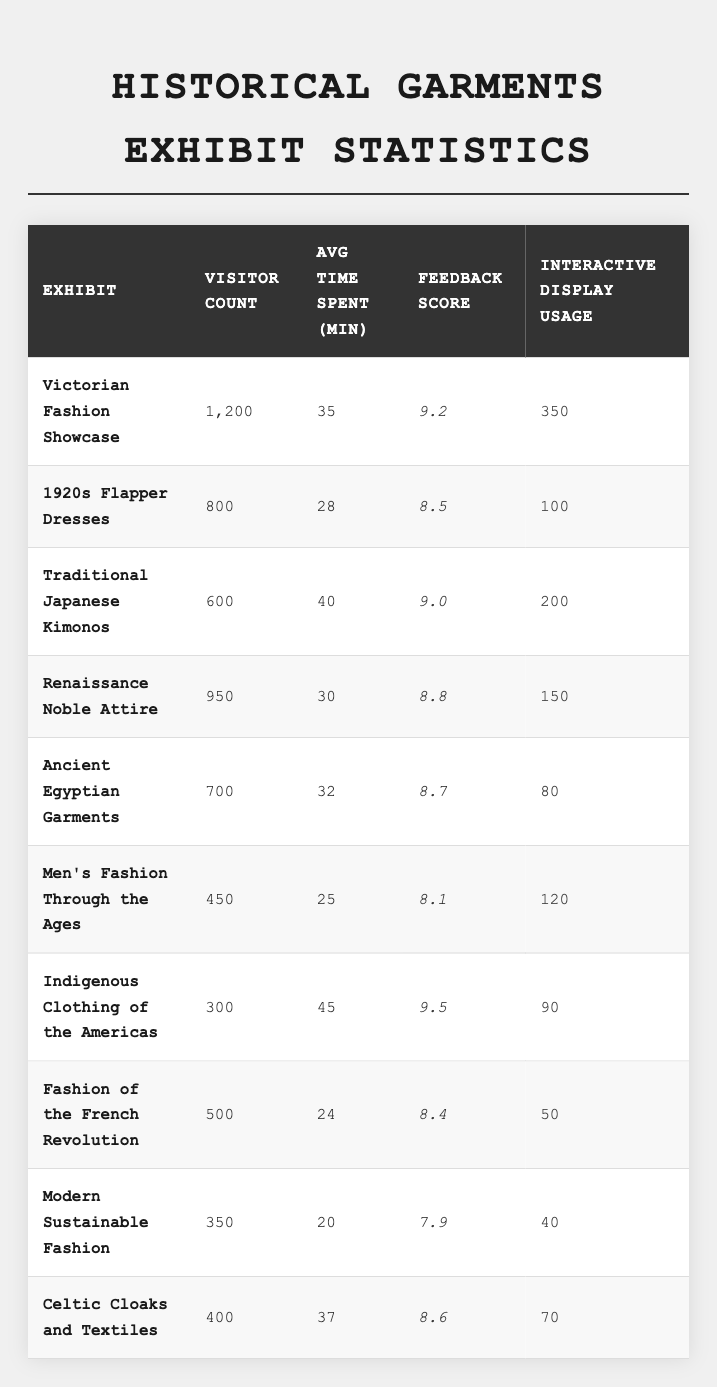What is the feedback score for the "Victorian Fashion Showcase"? The feedback score for the "Victorian Fashion Showcase" is listed in the table under the respective column, which shows a score of 9.2.
Answer: 9.2 Which exhibit had the highest visitor count? Looking at the visitor counts for each exhibit listed in the table, the "Victorian Fashion Showcase" has the highest count at 1200 visitors.
Answer: Victorian Fashion Showcase What is the average time spent by visitors at the "Traditional Japanese Kimonos" exhibit? The table indicates that visitors spent an average of 40 minutes at the "Traditional Japanese Kimonos" exhibit, which is the value in the corresponding row.
Answer: 40 minutes How many visitors engaged with the interactive display for the "1920s Flapper Dresses"? The table shows that for the "1920s Flapper Dresses" exhibit, the interactive display was used by 100 visitors according to the data provided.
Answer: 100 What is the average visitor count across all exhibits? First, sum the visitor counts: 1200 + 800 + 600 + 950 + 700 + 450 + 300 + 500 + 350 + 400 = 5,900. Then, divide by the number of exhibits (10) which yields 590.
Answer: 590 Did the "Indigenous Clothing of the Americas" have a higher feedback score than the "Ancient Egyptian Garments"? The feedback score for "Indigenous Clothing of the Americas" is 9.5, while that for "Ancient Egyptian Garments" is 8.7. Since 9.5 is greater than 8.7, the answer is yes.
Answer: Yes What is the total interactive display usage for all exhibits? Add the interactive display usage: 350 + 100 + 200 + 150 + 80 + 120 + 90 + 50 + 40 + 70 = 1,350. This is the total sum of all the interactive display usages from the table.
Answer: 1350 How much time, on average, did visitors spend at the "Men's Fashion Through the Ages" exhibit compared to the "Modern Sustainable Fashion" exhibit? The "Men's Fashion Through the Ages" exhibit had an average time spent of 25 minutes, while the "Modern Sustainable Fashion" exhibit had 20 minutes. Comparing, 25 minutes is greater than 20 minutes.
Answer: 25 minutes vs 20 minutes What percentage of visitors used the interactive display for the "Celtic Cloaks and Textiles"? To find this percentage, divide the interactive display usage (70) by the total visitors (400), then multiply by 100. So, (70/400) * 100 = 17.5%.
Answer: 17.5% Which exhibit had the lowest average time spent by visitors? From the table, "Modern Sustainable Fashion" has the lowest average time at 20 minutes, compared to the other exhibits.
Answer: Modern Sustainable Fashion 